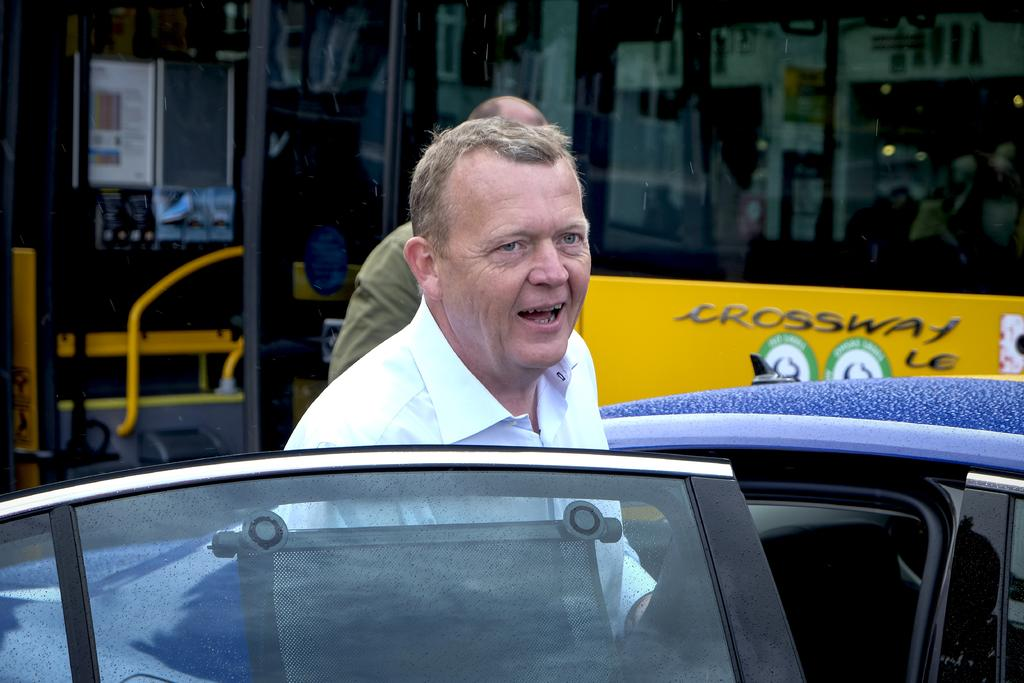What is the position of the first person in the image? The first person is standing behind a car door. Can you describe the position of the second person in the image? The second person is behind the first person. What can be seen in the background of the image? There is a bus in the background of the image. What type of cover is the toad using to protect itself from the rain in the image? There is no toad or rain present in the image; it features two people and a bus in the background. 